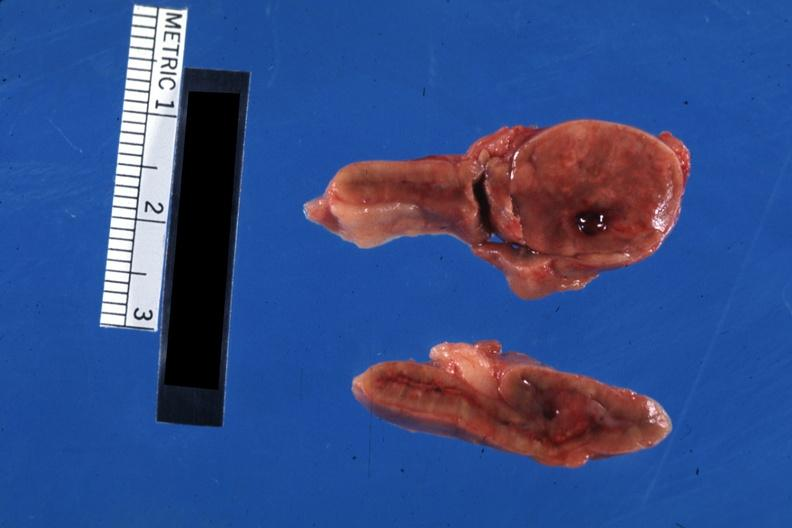what is present?
Answer the question using a single word or phrase. Endocrine 